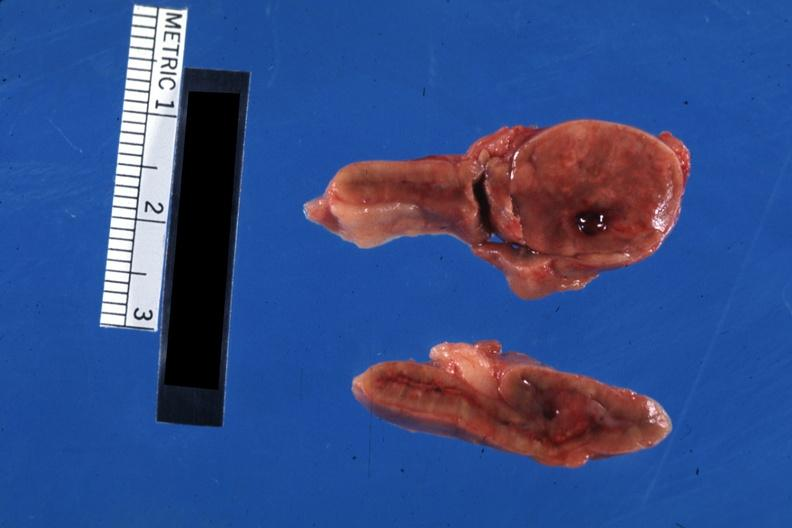what is present?
Answer the question using a single word or phrase. Endocrine 